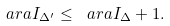<formula> <loc_0><loc_0><loc_500><loc_500>\ a r a I _ { { \Delta } ^ { \prime } } \leq \ a r a I _ { \Delta } + 1 .</formula> 